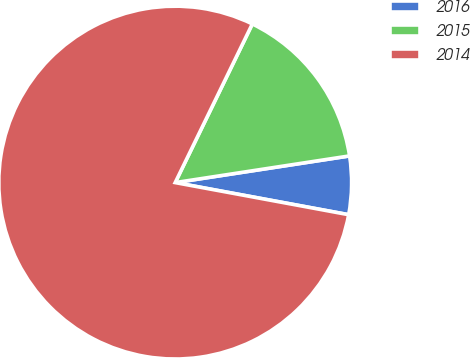Convert chart to OTSL. <chart><loc_0><loc_0><loc_500><loc_500><pie_chart><fcel>2016<fcel>2015<fcel>2014<nl><fcel>5.33%<fcel>15.38%<fcel>79.29%<nl></chart> 